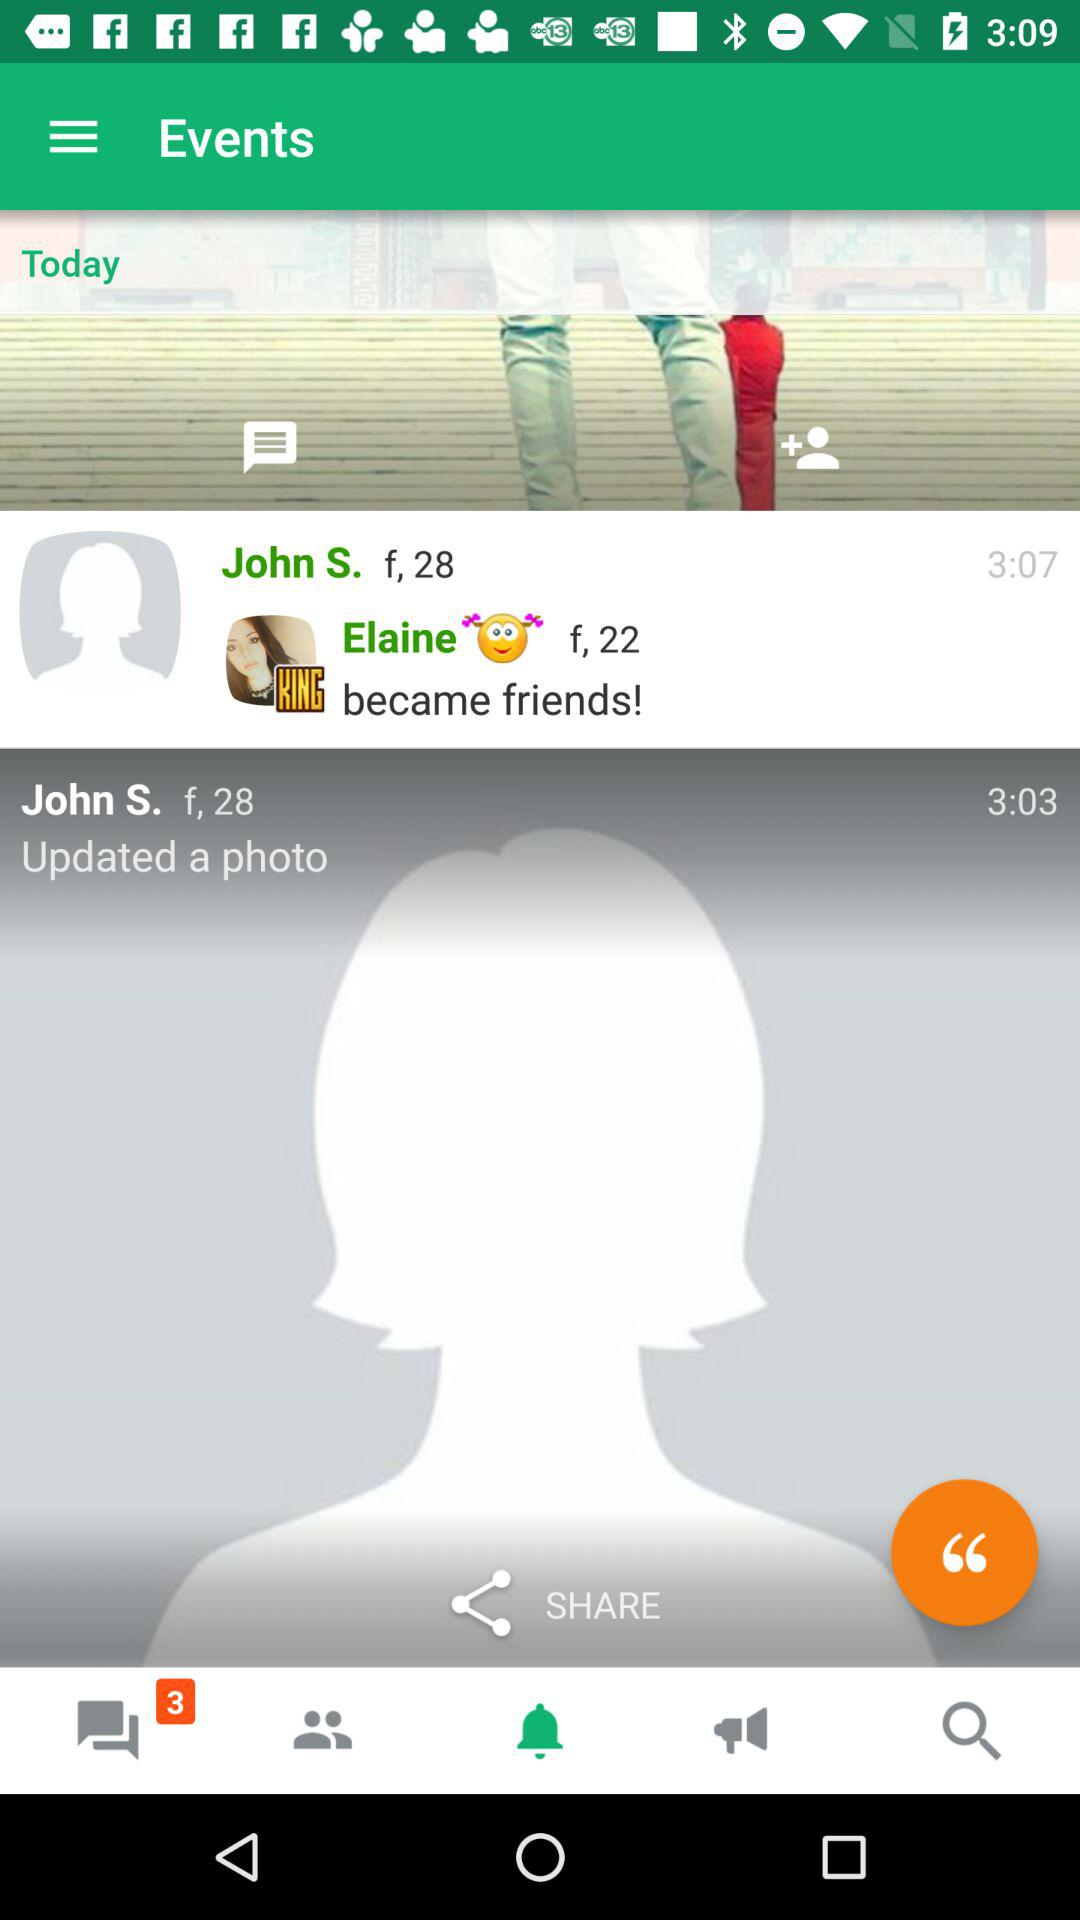Which tab is selected? The selected tab is "notification". 